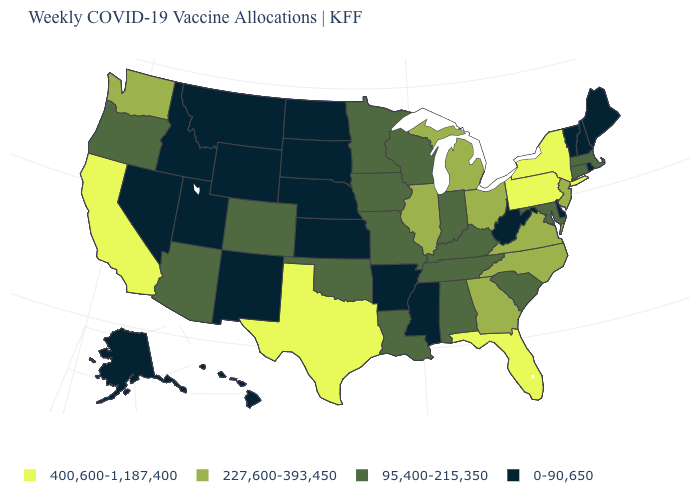Name the states that have a value in the range 0-90,650?
Quick response, please. Alaska, Arkansas, Delaware, Hawaii, Idaho, Kansas, Maine, Mississippi, Montana, Nebraska, Nevada, New Hampshire, New Mexico, North Dakota, Rhode Island, South Dakota, Utah, Vermont, West Virginia, Wyoming. Is the legend a continuous bar?
Short answer required. No. What is the value of West Virginia?
Give a very brief answer. 0-90,650. Among the states that border California , which have the highest value?
Keep it brief. Arizona, Oregon. What is the highest value in states that border South Carolina?
Keep it brief. 227,600-393,450. Does the first symbol in the legend represent the smallest category?
Be succinct. No. Among the states that border Louisiana , which have the highest value?
Be succinct. Texas. Among the states that border Arkansas , which have the highest value?
Concise answer only. Texas. Which states hav the highest value in the MidWest?
Give a very brief answer. Illinois, Michigan, Ohio. Among the states that border Massachusetts , does New York have the highest value?
Short answer required. Yes. What is the value of North Carolina?
Be succinct. 227,600-393,450. Among the states that border Colorado , does Utah have the lowest value?
Be succinct. Yes. Name the states that have a value in the range 400,600-1,187,400?
Write a very short answer. California, Florida, New York, Pennsylvania, Texas. Which states have the highest value in the USA?
Short answer required. California, Florida, New York, Pennsylvania, Texas. What is the highest value in the USA?
Give a very brief answer. 400,600-1,187,400. 